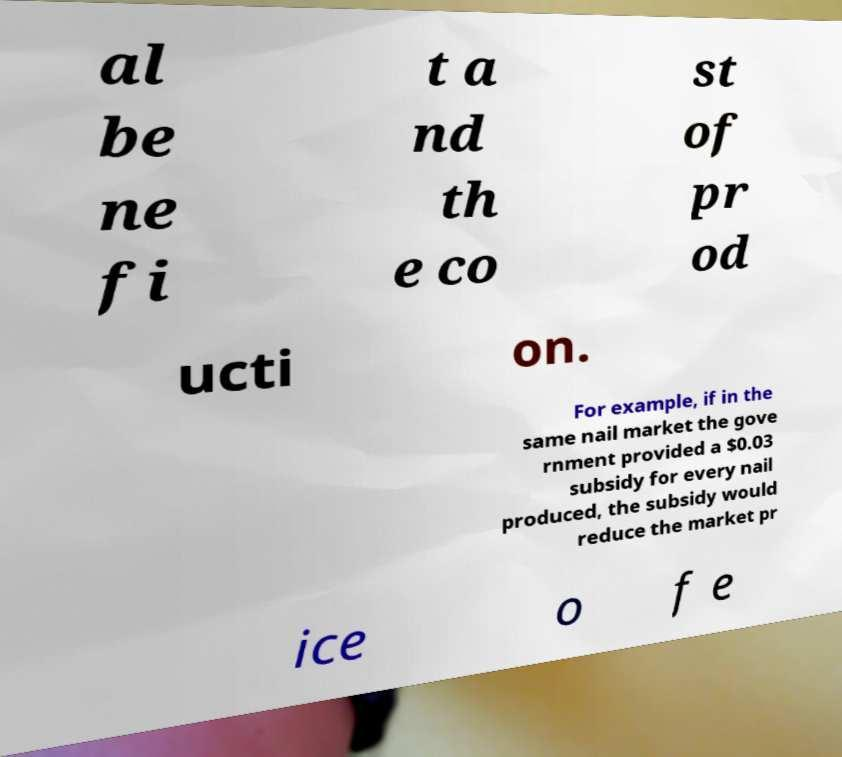I need the written content from this picture converted into text. Can you do that? al be ne fi t a nd th e co st of pr od ucti on. For example, if in the same nail market the gove rnment provided a $0.03 subsidy for every nail produced, the subsidy would reduce the market pr ice o f e 